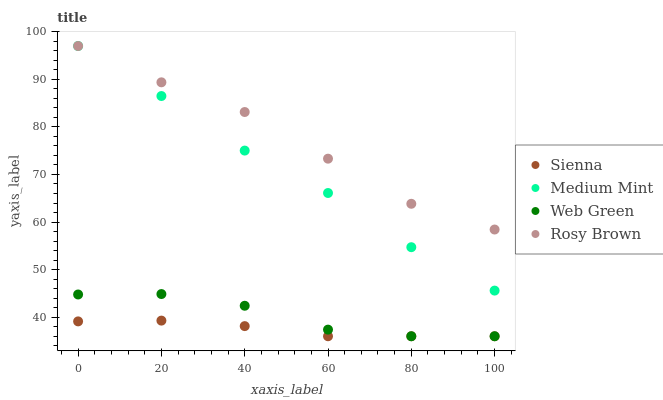Does Sienna have the minimum area under the curve?
Answer yes or no. Yes. Does Rosy Brown have the maximum area under the curve?
Answer yes or no. Yes. Does Medium Mint have the minimum area under the curve?
Answer yes or no. No. Does Medium Mint have the maximum area under the curve?
Answer yes or no. No. Is Sienna the smoothest?
Answer yes or no. Yes. Is Web Green the roughest?
Answer yes or no. Yes. Is Medium Mint the smoothest?
Answer yes or no. No. Is Medium Mint the roughest?
Answer yes or no. No. Does Sienna have the lowest value?
Answer yes or no. Yes. Does Medium Mint have the lowest value?
Answer yes or no. No. Does Rosy Brown have the highest value?
Answer yes or no. Yes. Does Web Green have the highest value?
Answer yes or no. No. Is Sienna less than Medium Mint?
Answer yes or no. Yes. Is Medium Mint greater than Sienna?
Answer yes or no. Yes. Does Sienna intersect Web Green?
Answer yes or no. Yes. Is Sienna less than Web Green?
Answer yes or no. No. Is Sienna greater than Web Green?
Answer yes or no. No. Does Sienna intersect Medium Mint?
Answer yes or no. No. 